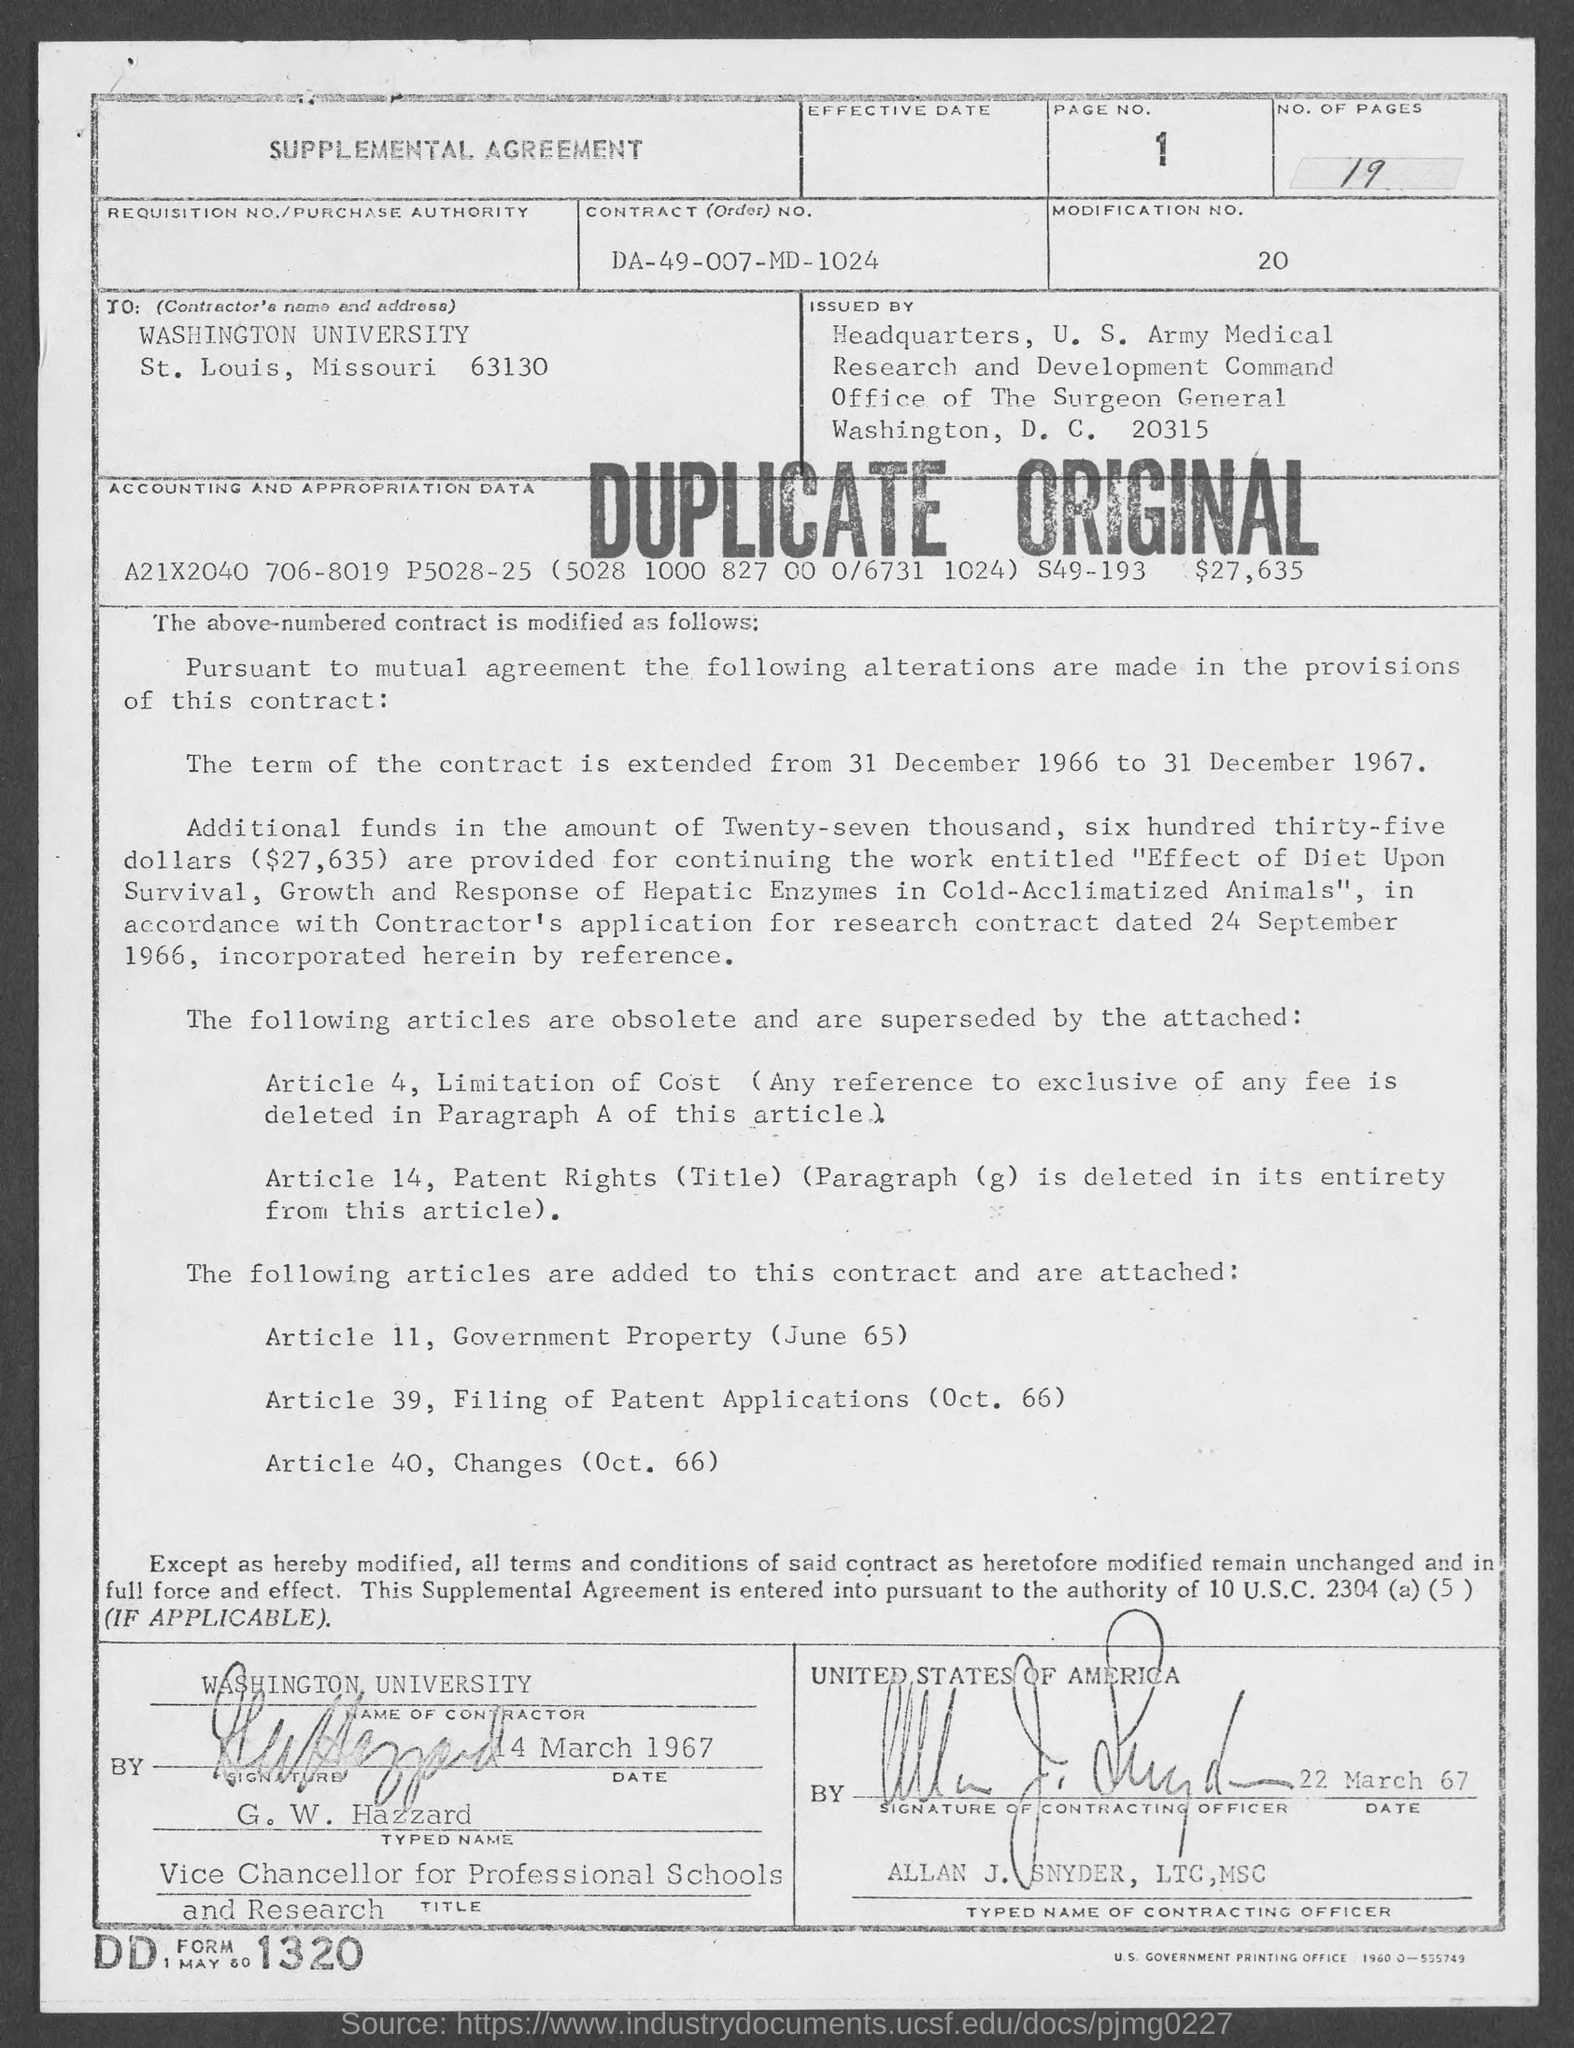How many no. of pages are there in the given agreement ?
Your answer should be compact. 19. What is the page no. mentioned in the given agreement ?
Keep it short and to the point. 1. What is the modification no. mentioned in the given agreement ?
Offer a very short reply. 20. What is the contract (order) no. mentioned in the given agreement ?
Give a very brief answer. Da-49-007-md-1024. What is the name of the university mentioned in the given agreement ?
Keep it short and to the point. Washington university. What is the article 11, mentioned in the given agreement ?
Offer a very short reply. Government property (june 65). What is the article 39, mentioned in the given agreement ?
Keep it short and to the point. Filing of patent applications (oct. 66). What is the name of the signature of contracting officer ?
Your answer should be compact. Allan j. snyder. 